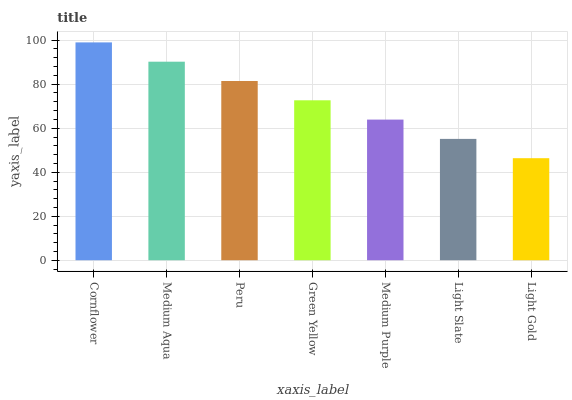Is Medium Aqua the minimum?
Answer yes or no. No. Is Medium Aqua the maximum?
Answer yes or no. No. Is Cornflower greater than Medium Aqua?
Answer yes or no. Yes. Is Medium Aqua less than Cornflower?
Answer yes or no. Yes. Is Medium Aqua greater than Cornflower?
Answer yes or no. No. Is Cornflower less than Medium Aqua?
Answer yes or no. No. Is Green Yellow the high median?
Answer yes or no. Yes. Is Green Yellow the low median?
Answer yes or no. Yes. Is Cornflower the high median?
Answer yes or no. No. Is Cornflower the low median?
Answer yes or no. No. 